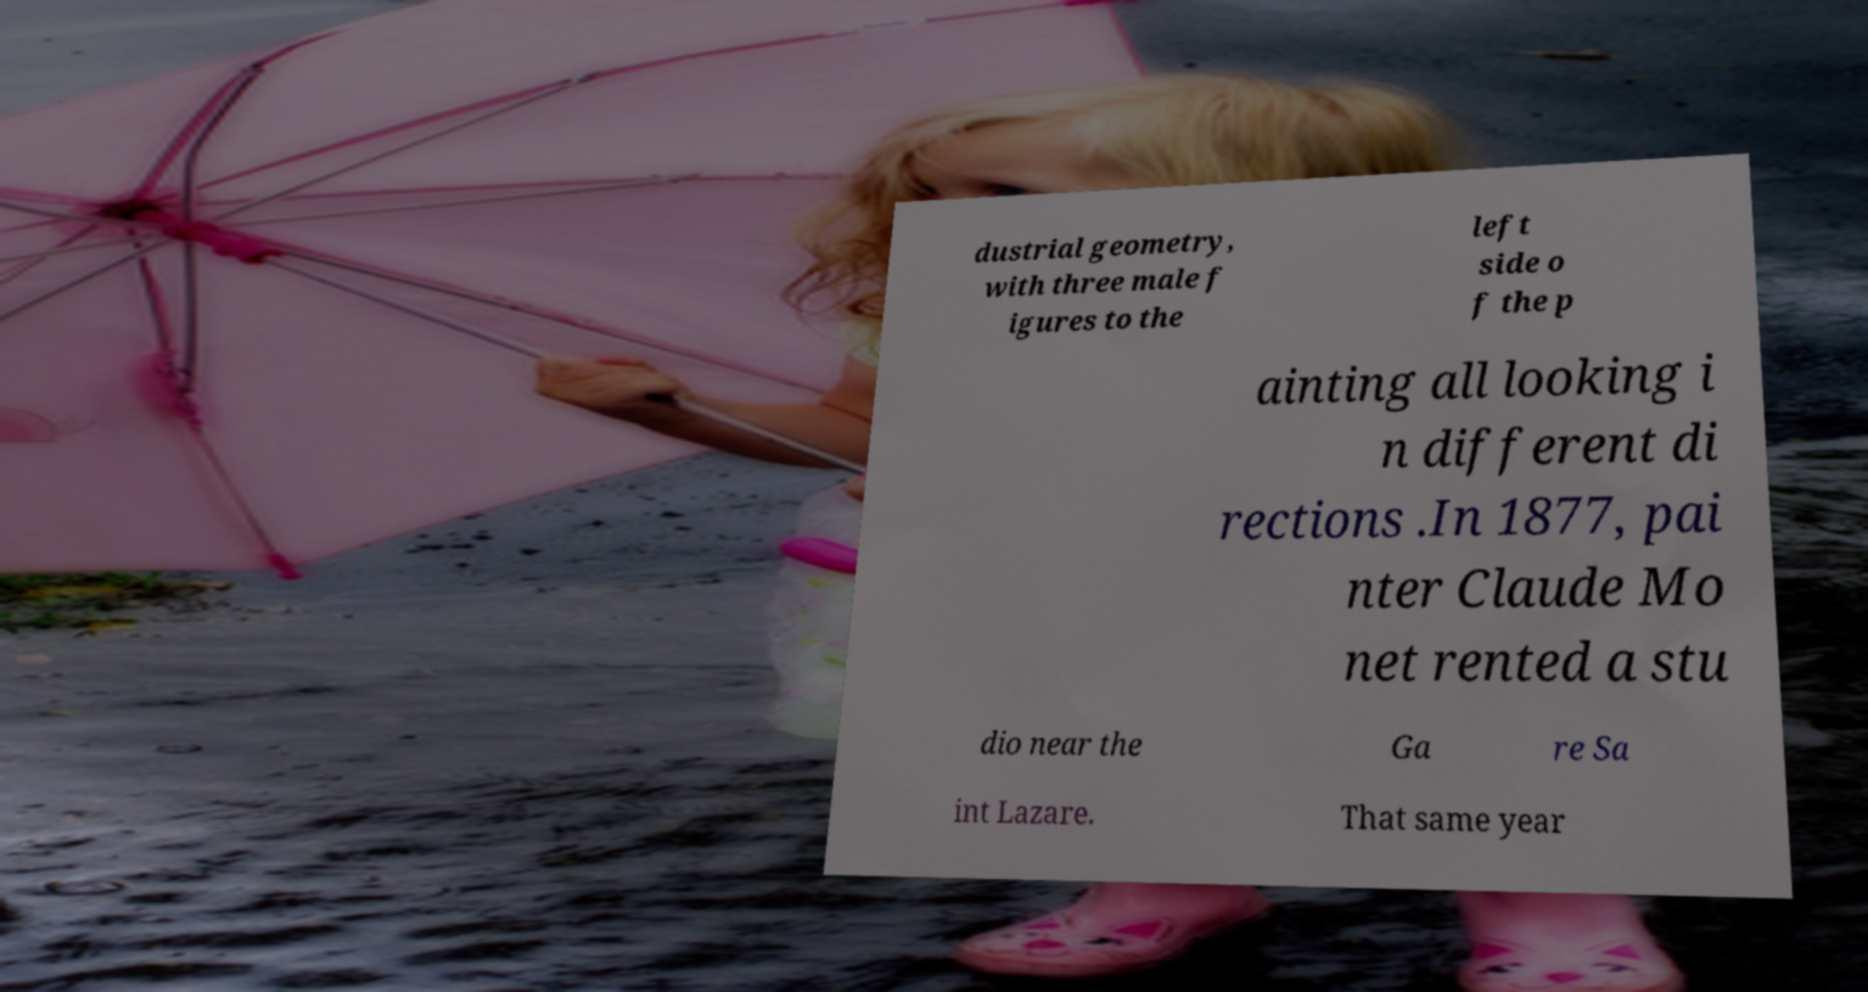What messages or text are displayed in this image? I need them in a readable, typed format. dustrial geometry, with three male f igures to the left side o f the p ainting all looking i n different di rections .In 1877, pai nter Claude Mo net rented a stu dio near the Ga re Sa int Lazare. That same year 